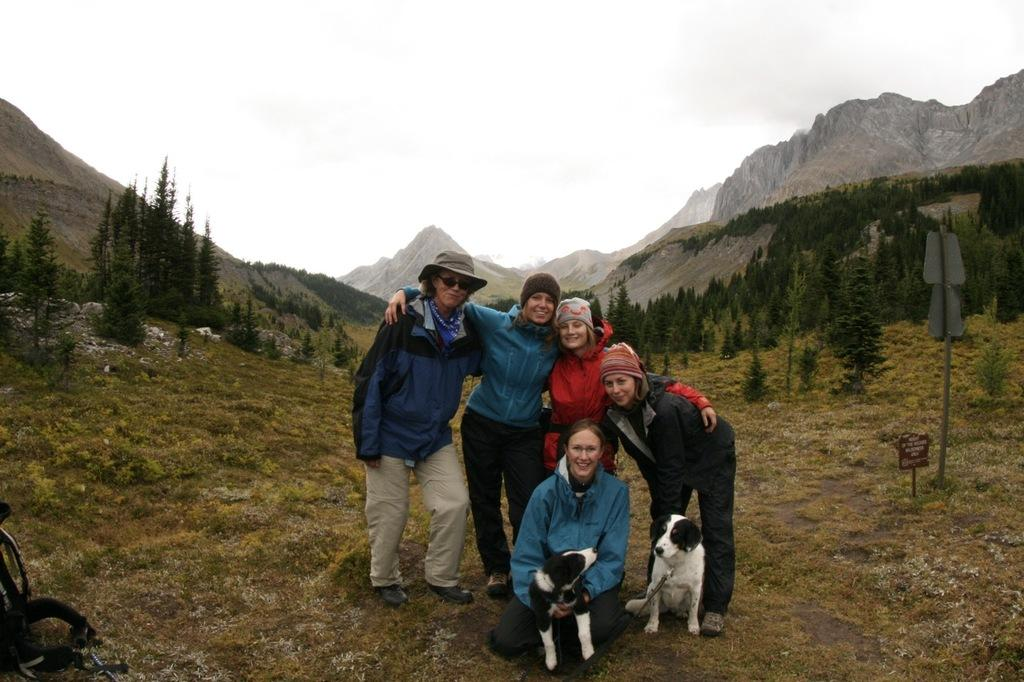What is happening in the foreground of the image? There are people in the foreground of the image, and they are posing for a photo. What type of surface can be seen beneath the people? There is a grass surface in the image. What can be seen in the background of the image? There are trees and mountains in the background of the image. How many ants can be seen carrying a hydrant in the image? There are no ants or hydrants present in the image. What type of balance do the people in the image need to maintain while posing for the photo? The people in the image do not need to maintain any specific balance while posing for the photo, as they are standing on a flat grass surface. 